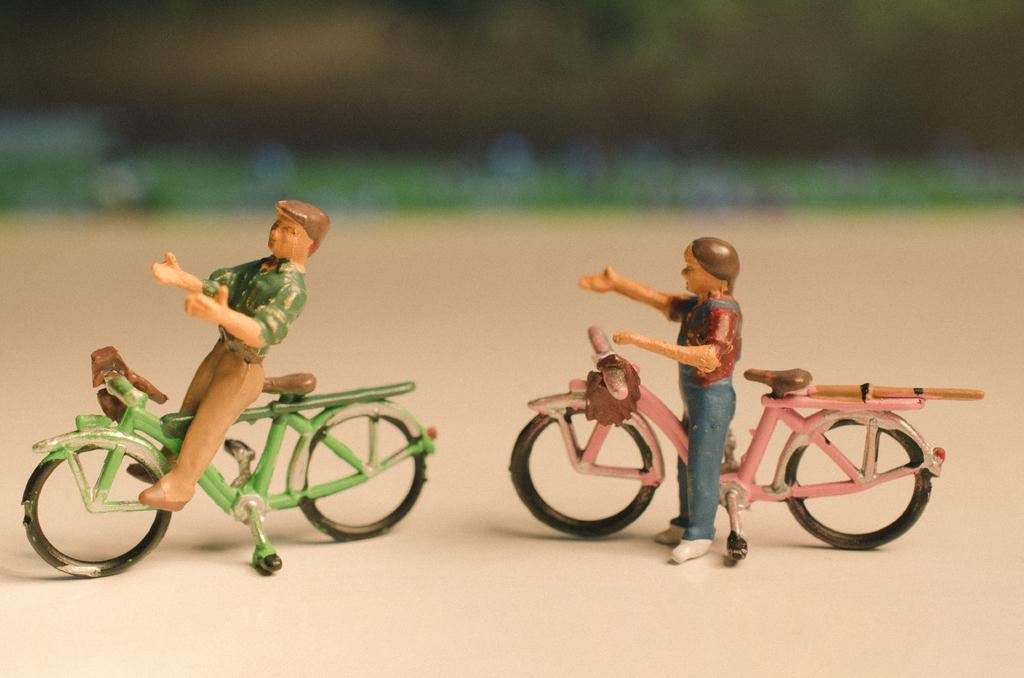How would you summarize this image in a sentence or two? This picture shows a two toys of a man and a bicycle placed on the table. 